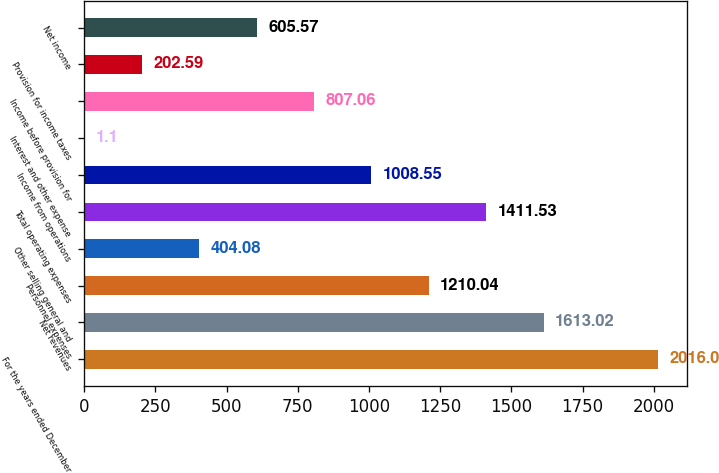Convert chart to OTSL. <chart><loc_0><loc_0><loc_500><loc_500><bar_chart><fcel>For the years ended December<fcel>Net revenues<fcel>Personnel expenses<fcel>Other selling general and<fcel>Total operating expenses<fcel>Income from operations<fcel>Interest and other expense<fcel>Income before provision for<fcel>Provision for income taxes<fcel>Net income<nl><fcel>2016<fcel>1613.02<fcel>1210.04<fcel>404.08<fcel>1411.53<fcel>1008.55<fcel>1.1<fcel>807.06<fcel>202.59<fcel>605.57<nl></chart> 